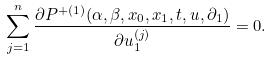<formula> <loc_0><loc_0><loc_500><loc_500>\sum _ { j = 1 } ^ { n } \frac { \partial P ^ { + ( 1 ) } ( \alpha , \beta , x _ { 0 } , x _ { 1 } , t , u , \partial _ { 1 } ) } { \partial u _ { 1 } ^ { ( j ) } } = 0 .</formula> 